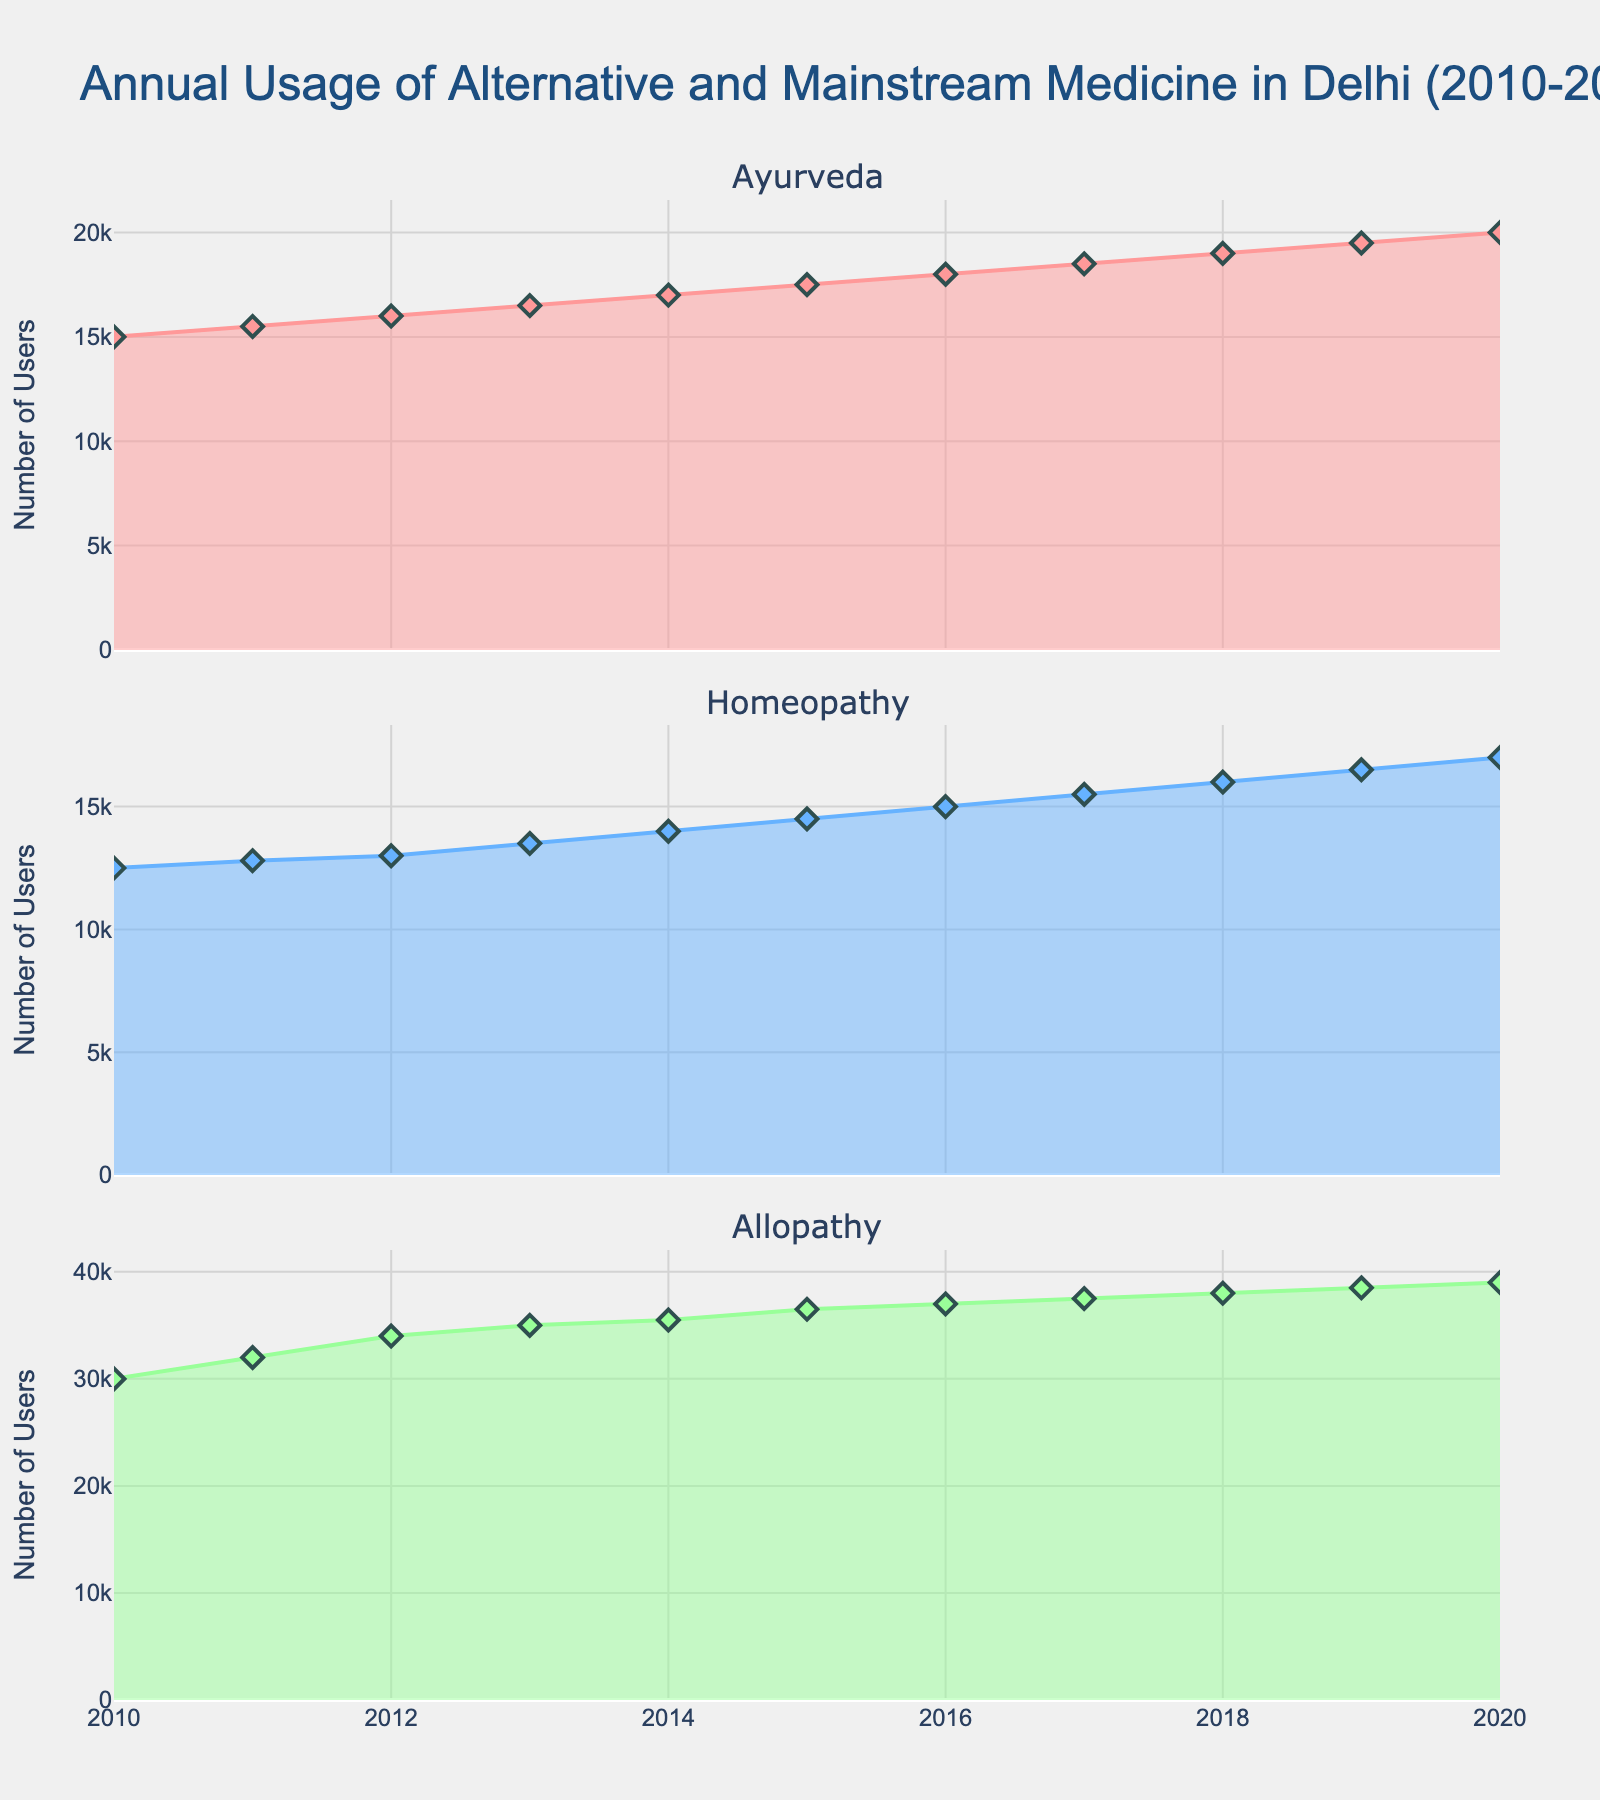What is the title of the entire figure? The title of the entire figure appears at the top and summarizes the visual information presented. It is "Annual Usage of Alternative and Mainstream Medicine in Delhi (2010-2020)".
Answer: Annual Usage of Alternative and Mainstream Medicine in Delhi (2010-2020) How many subplots are there in the figure? The figure contains three separate subplots, each representing one type of medicine: Ayurveda, Homeopathy, and Allopathy.
Answer: 3 Which type of medicine had the highest usage in 2015? By reviewing the y-axes of the subplots, Allopathy clearly has the highest value in 2015 among the three types of medicines.
Answer: Allopathy What is the color used to represent Homeopathy? The color for Homeopathy is visualized through the specific shaded area in its subplot. It is represented with a blue color.
Answer: Blue By how much did the usage of Ayurveda increase from 2010 to 2020? The number of users of Ayurveda in 2010 is 15,000 and in 2020 is 20,000. The increase is calculated by subtracting the 2010 value from the 2020 value: 20,000 - 15,000 = 5,000.
Answer: 5,000 Which type of medicine shows the smallest increment in usage from 2010 to 2020? Reviewing the end points of each subplot, Homeopathy shows the smallest increase from 12,500 in 2010 to 17,000 in 2020, which is an increment of 4,500. Ayurveda increased by 5,000 and Allopathy by 9,000.
Answer: Homeopathy What are the y-axis titles in the subplots? The y-axes of all three subplots have the same title, which is "Number of Users". This indicates the data being measured along the vertical axis.
Answer: Number of Users In which year did the usage of Allopathy reach 37,000? By looking at the values in the Allopathy subplot, the usage reached 37,000 in the year 2016.
Answer: 2016 Compare the total usage (sum) of all three types of medicines in the year 2018. First, identify the number of users for each medicine in 2018: Ayurveda (19,000), Homeopathy (16,000), Allopathy (38,000). Sum them up: 19,000 + 16,000 + 38,000 = 73,000.
Answer: 73,000 Which type of medicine consistently had the lowest usage from 2010 to 2020? By observing all subplots across the entire time range, Homeopathy consistently shows the lowest usage when compared to Ayurveda and Allopathy.
Answer: Homeopathy 